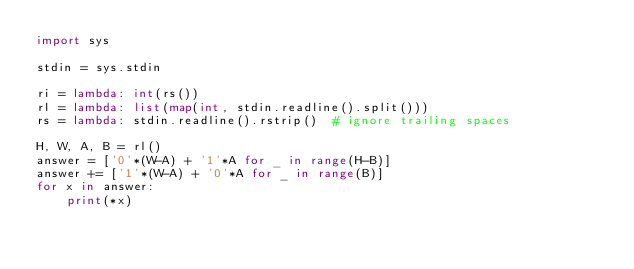<code> <loc_0><loc_0><loc_500><loc_500><_Python_>import sys

stdin = sys.stdin

ri = lambda: int(rs())
rl = lambda: list(map(int, stdin.readline().split()))
rs = lambda: stdin.readline().rstrip()  # ignore trailing spaces

H, W, A, B = rl()
answer = ['0'*(W-A) + '1'*A for _ in range(H-B)]
answer += ['1'*(W-A) + '0'*A for _ in range(B)]
for x in answer:
    print(*x)
</code> 